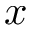<formula> <loc_0><loc_0><loc_500><loc_500>x</formula> 